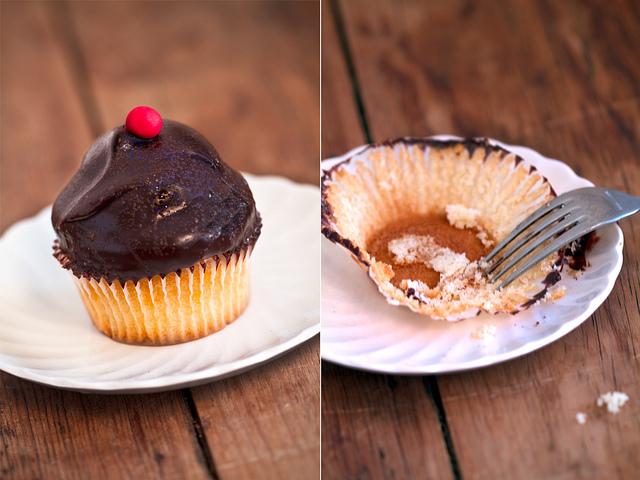Which side has a full cupcake?
Short answer required. Left. Is the icing chocolate flavored?
Short answer required. Yes. What kind of frosting is on the cupcake?
Give a very brief answer. Chocolate. What color is the frosting?
Quick response, please. Brown. Is the silverware typically used for the item being eaten?
Keep it brief. No. 